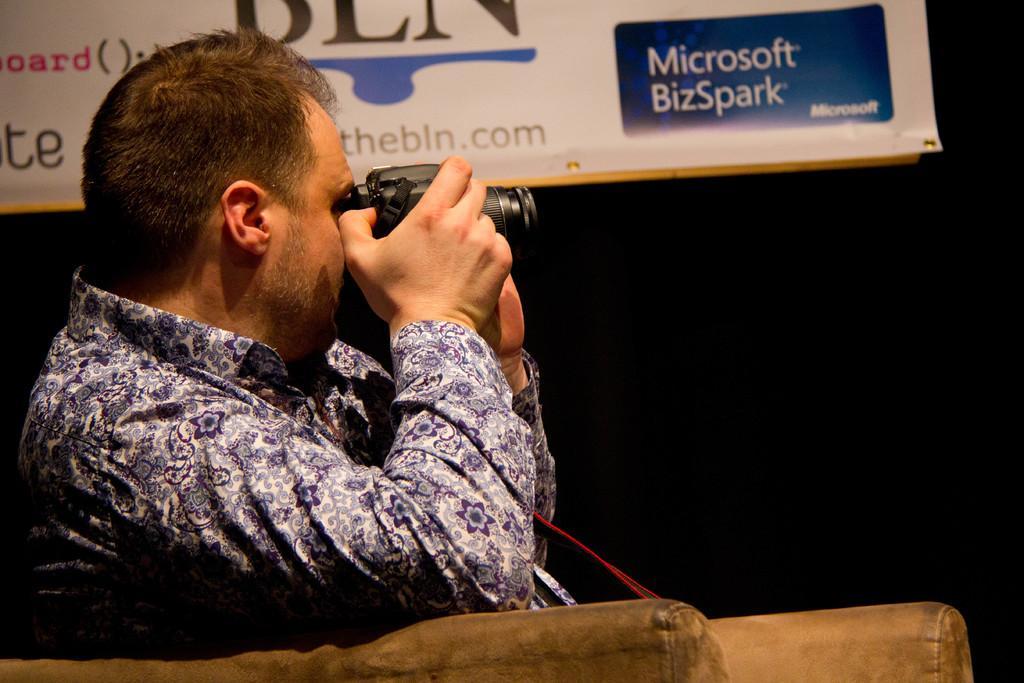Please provide a concise description of this image. Here we can see a person sitting on a sofa and he is clicking an image with a camera. 